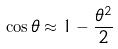<formula> <loc_0><loc_0><loc_500><loc_500>\cos \theta \approx 1 - \frac { \theta ^ { 2 } } { 2 }</formula> 